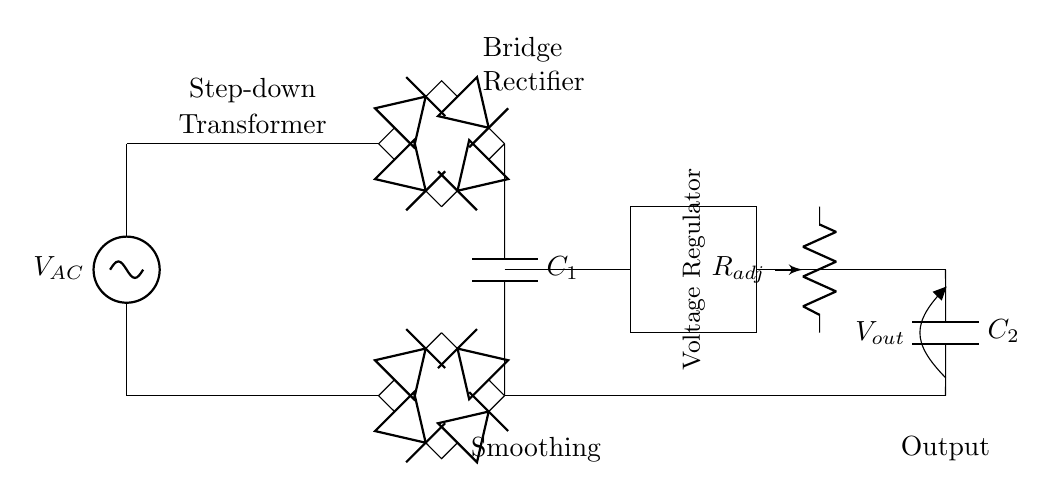what type of circuit is shown? The circuit is a variable voltage power supply circuit, which converts AC voltage into a regulated DC voltage suitable for testing materials.
Answer: variable voltage power supply circuit what does the transformer do? The transformer steps down the input AC voltage to a lower AC voltage. In the diagram, it takes the high voltage AC from the source and reduces it before the rectification process.
Answer: steps down voltage how many diodes are in the bridge rectifier? The bridge rectifier consists of four diodes connected in a specific arrangement to convert AC to DC, as shown in the circuit.
Answer: four diodes what components smooth the DC output? The smoothing capacitor, labeled C1, is employed to reduce voltage fluctuations and provide a steady DC output. Additionally, a second capacitor, labeled C2, is connected at the output for further smoothing.
Answer: C1 and C2 what is the purpose of the potentiometer in this circuit? The potentiometer allows for fine-tuning of the output voltage, enabling the user to adjust the voltage level based on specific material characterization needs.
Answer: voltage adjustment how does the circuit improve the quality of the output voltage? The combination of the bridge rectifier and the smoothing capacitors minimizes voltage ripple, ensuring a stable and clean DC output suitable for precise measurements in material characterization applications.
Answer: minimizes voltage ripple what is the output voltage labeled as? The output voltage is labeled as Vout in the circuit diagram, indicating the voltage available for the material characterization equipment after regulation and smoothing.
Answer: Vout 